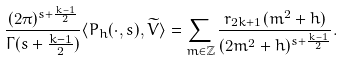Convert formula to latex. <formula><loc_0><loc_0><loc_500><loc_500>\frac { ( 2 \pi ) ^ { s + \frac { k - 1 } { 2 } } } { \Gamma ( s + \frac { k - 1 } { 2 } ) } \langle P _ { h } ( \cdot , s ) , \widetilde { V } \rangle = \sum _ { m \in \mathbb { Z } } \frac { r _ { 2 k + 1 } ( m ^ { 2 } + h ) } { ( 2 m ^ { 2 } + h ) ^ { s + \frac { k - 1 } { 2 } } } .</formula> 